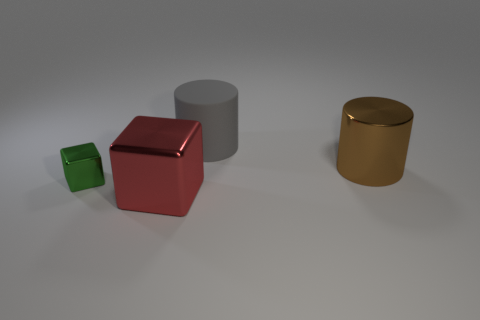There is a thing that is both on the right side of the small shiny block and on the left side of the matte cylinder; what size is it?
Offer a terse response. Large. Are there any other large things that have the same shape as the brown object?
Keep it short and to the point. Yes. There is a gray object right of the big shiny object that is left of the object that is behind the brown thing; what is its material?
Give a very brief answer. Rubber. Are there any red rubber cubes that have the same size as the gray rubber cylinder?
Provide a short and direct response. No. What color is the metallic cube behind the large shiny object that is in front of the green metal cube?
Keep it short and to the point. Green. How many large things are there?
Keep it short and to the point. 3. Is the color of the large block the same as the metal cylinder?
Ensure brevity in your answer.  No. Are there fewer tiny things behind the brown metallic object than green metallic cubes that are left of the rubber object?
Provide a succinct answer. Yes. What is the color of the matte thing?
Your answer should be compact. Gray. What number of large metal cubes are the same color as the small cube?
Provide a short and direct response. 0. 